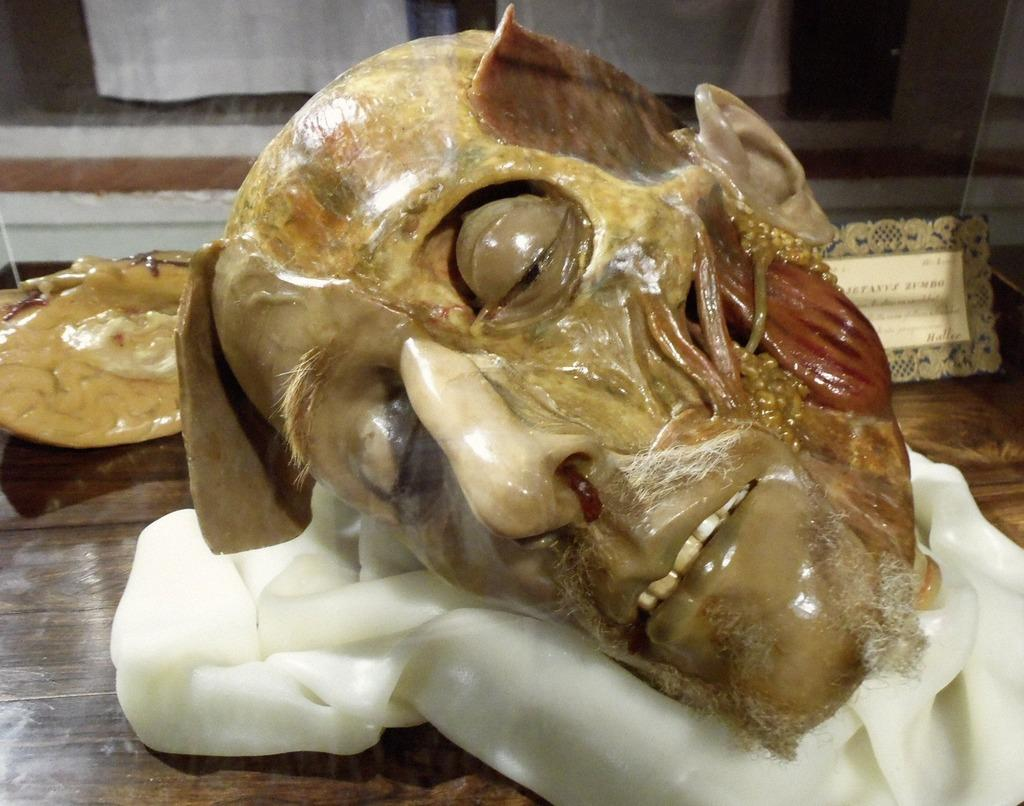What can be seen on the person's face in the image? The person's face is visible in the image, but no specific details about their facial expression or features are provided. What is the board used for in the image? The purpose of the board in the image is not clear from the provided facts. What items are on the table in the image? The facts only mention that there are things on the table, but no specific details are provided. What type of window treatment is present in the image? Curtains are present in the image, which suggests they are used as window treatments. What type of footwear is the person wearing in the image? There is no information about the person's footwear in the image. Can you tell me how many skateboards are visible in the image? There is no mention of skateboards in the image. What ingredients are used to make the stew in the image? There is no stew present in the image. 